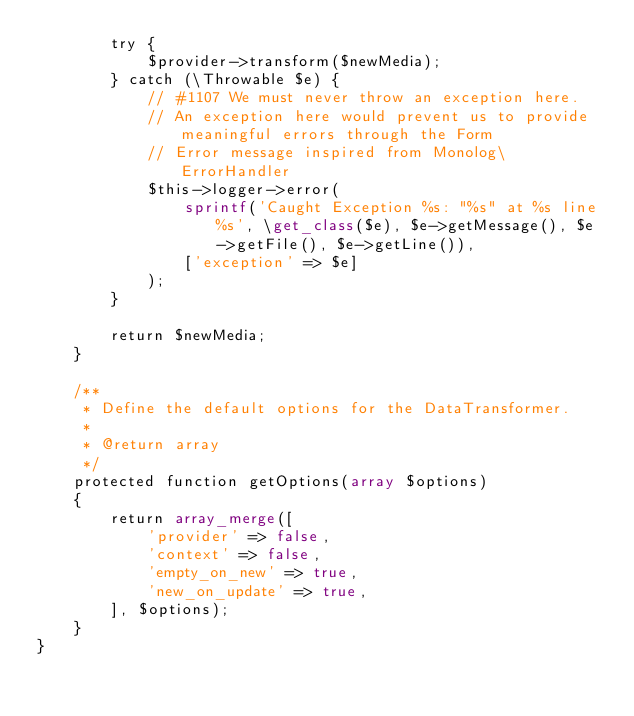<code> <loc_0><loc_0><loc_500><loc_500><_PHP_>        try {
            $provider->transform($newMedia);
        } catch (\Throwable $e) {
            // #1107 We must never throw an exception here.
            // An exception here would prevent us to provide meaningful errors through the Form
            // Error message inspired from Monolog\ErrorHandler
            $this->logger->error(
                sprintf('Caught Exception %s: "%s" at %s line %s', \get_class($e), $e->getMessage(), $e->getFile(), $e->getLine()),
                ['exception' => $e]
            );
        }

        return $newMedia;
    }

    /**
     * Define the default options for the DataTransformer.
     *
     * @return array
     */
    protected function getOptions(array $options)
    {
        return array_merge([
            'provider' => false,
            'context' => false,
            'empty_on_new' => true,
            'new_on_update' => true,
        ], $options);
    }
}
</code> 